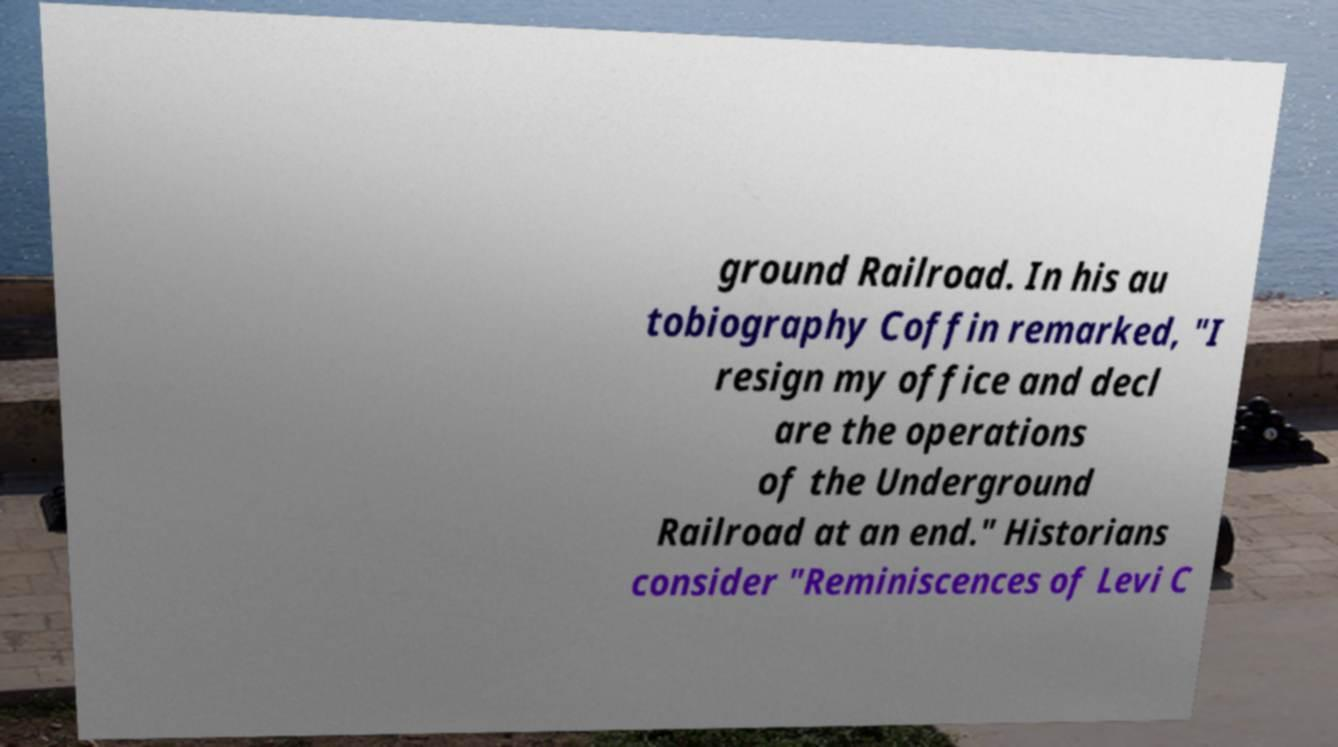I need the written content from this picture converted into text. Can you do that? ground Railroad. In his au tobiography Coffin remarked, "I resign my office and decl are the operations of the Underground Railroad at an end." Historians consider "Reminiscences of Levi C 